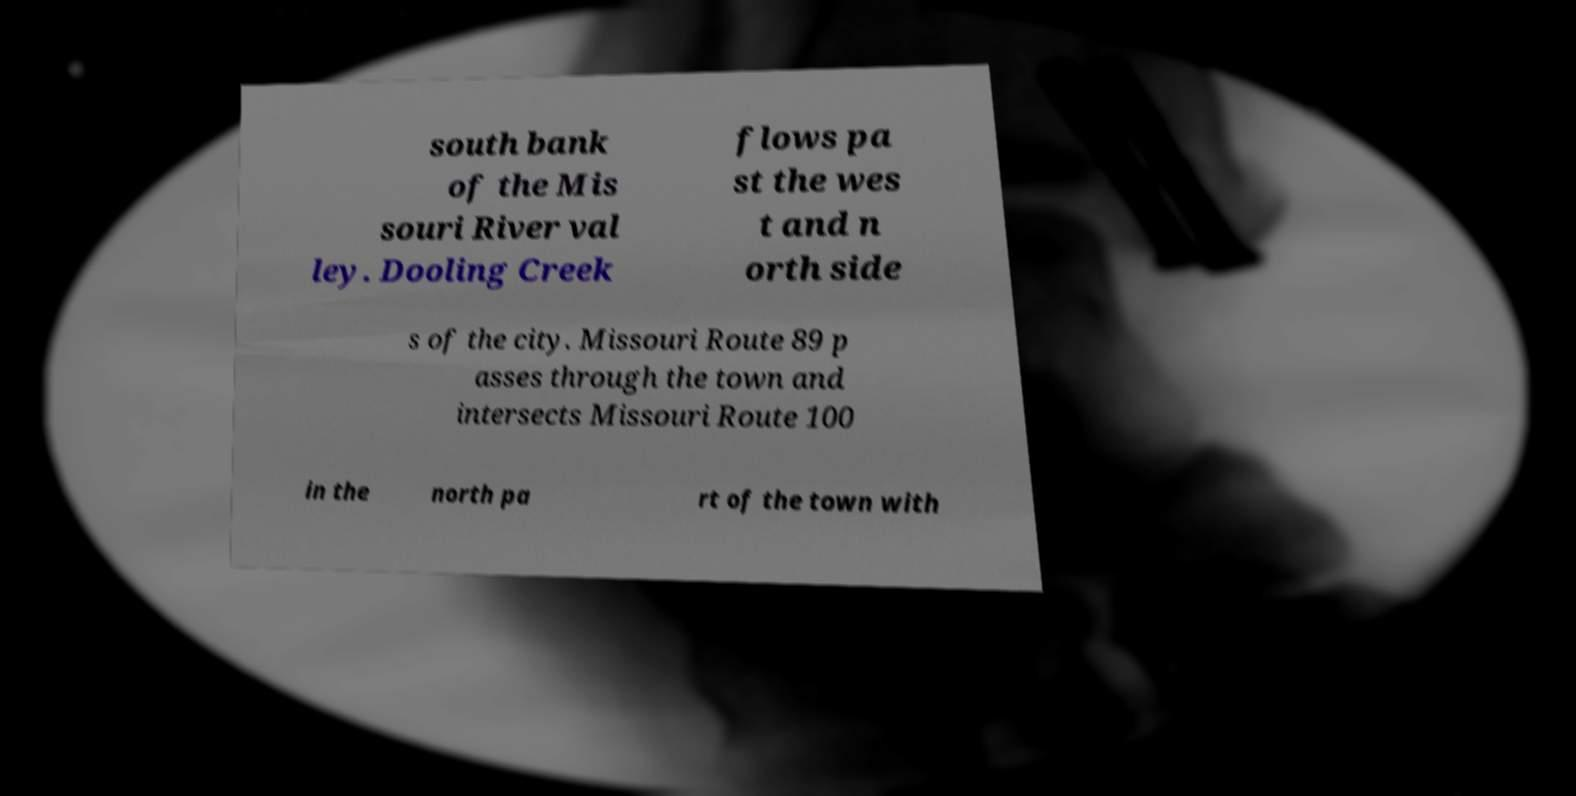Can you read and provide the text displayed in the image?This photo seems to have some interesting text. Can you extract and type it out for me? south bank of the Mis souri River val ley. Dooling Creek flows pa st the wes t and n orth side s of the city. Missouri Route 89 p asses through the town and intersects Missouri Route 100 in the north pa rt of the town with 